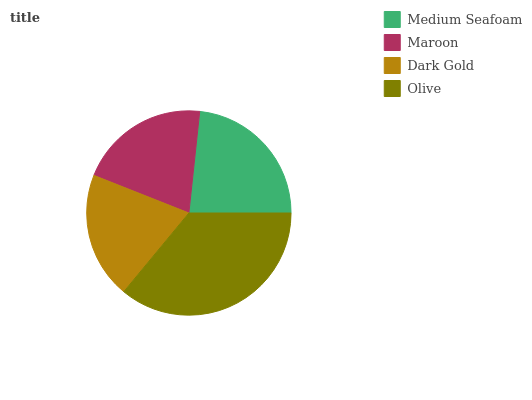Is Dark Gold the minimum?
Answer yes or no. Yes. Is Olive the maximum?
Answer yes or no. Yes. Is Maroon the minimum?
Answer yes or no. No. Is Maroon the maximum?
Answer yes or no. No. Is Medium Seafoam greater than Maroon?
Answer yes or no. Yes. Is Maroon less than Medium Seafoam?
Answer yes or no. Yes. Is Maroon greater than Medium Seafoam?
Answer yes or no. No. Is Medium Seafoam less than Maroon?
Answer yes or no. No. Is Medium Seafoam the high median?
Answer yes or no. Yes. Is Maroon the low median?
Answer yes or no. Yes. Is Olive the high median?
Answer yes or no. No. Is Olive the low median?
Answer yes or no. No. 